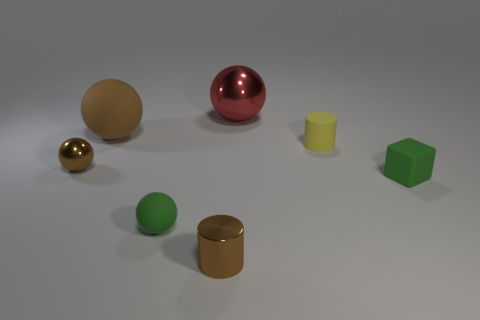Subtract all yellow cylinders. How many cylinders are left? 1 Subtract all tiny green matte spheres. How many spheres are left? 3 Subtract 0 green cylinders. How many objects are left? 7 Subtract all cylinders. How many objects are left? 5 Subtract 1 blocks. How many blocks are left? 0 Subtract all gray cylinders. Subtract all red blocks. How many cylinders are left? 2 Subtract all purple cubes. How many brown cylinders are left? 1 Subtract all small brown balls. Subtract all purple balls. How many objects are left? 6 Add 3 big metal balls. How many big metal balls are left? 4 Add 5 green balls. How many green balls exist? 6 